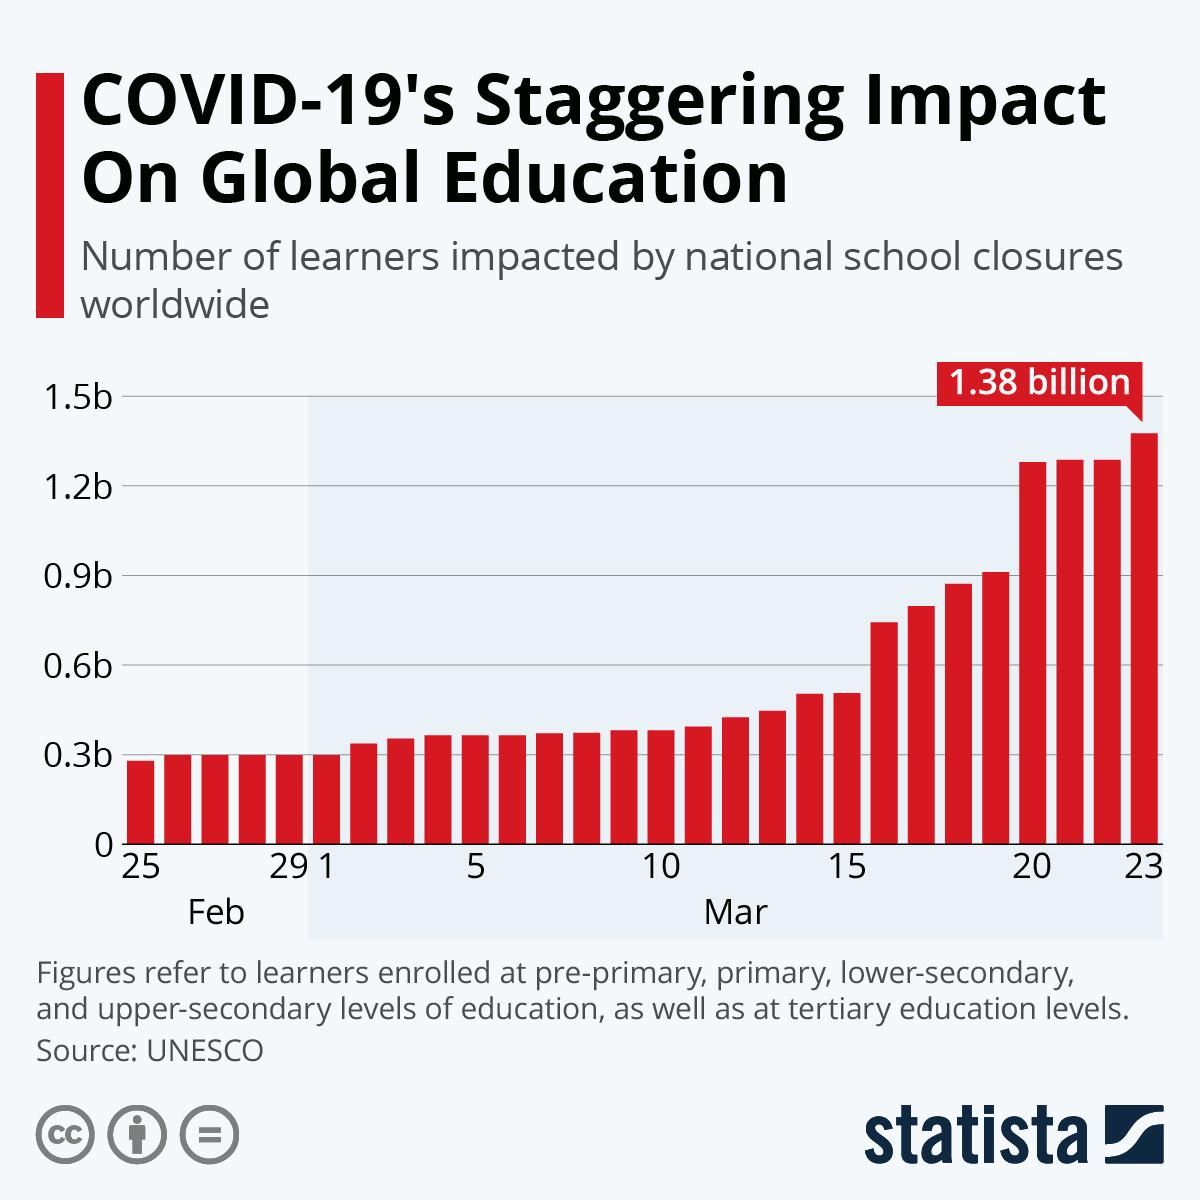Identify some key points in this picture. On February 25th, the learners who were impacted had a less than 0.3b amount. As of March 20th, more than 1.2 billion learners have been impacted by school closures. 